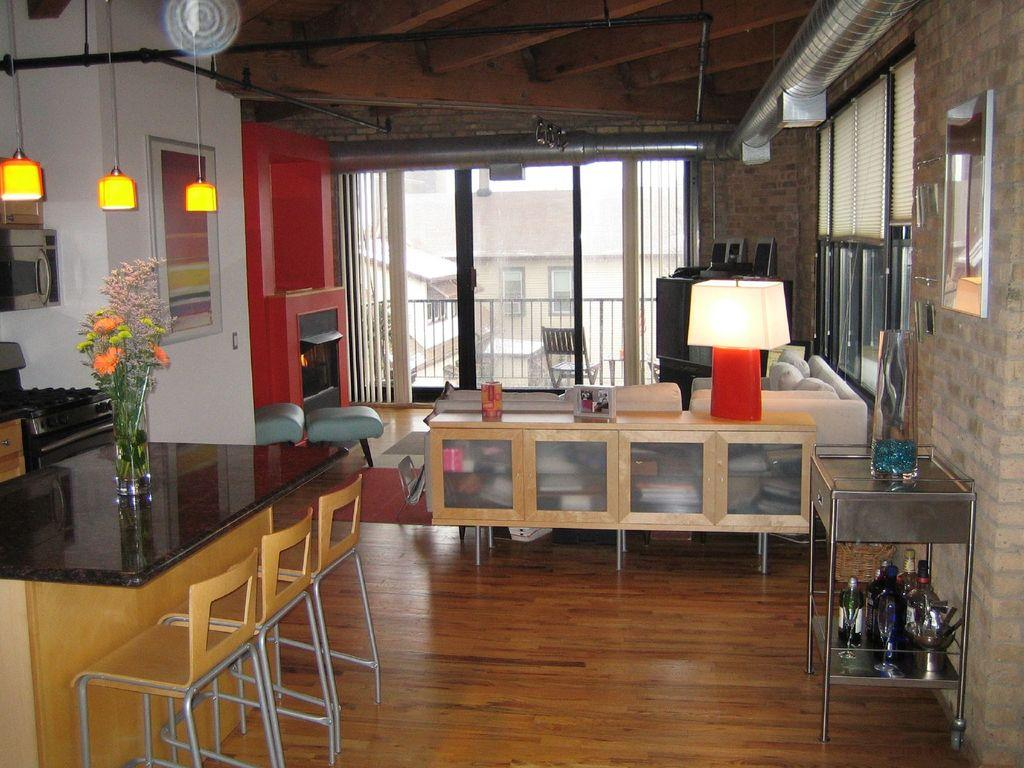What type of furniture is present in the image? There are chairs in the image. Where are the chairs located? The chairs are on the floor. What type of decoration can be seen in the image? There are flowers in a vase in the image. What type of lighting is visible in the image? There are lights on the top of the image. What type of lamp is present on a table in the image? There is a table lamp on a table in the image. What type of ink is used to write the advice on the chairs in the image? There is no advice written on the chairs in the image, and therefore no ink is involved. 